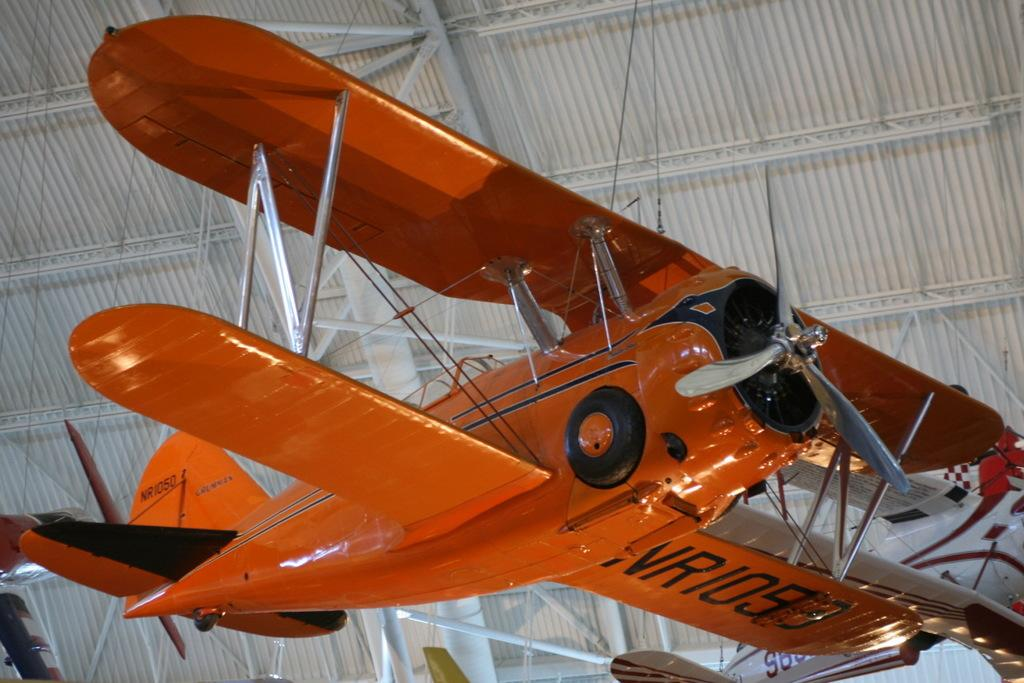What is the main subject of the image? The main subject of the image is an airplane. Where is the airplane located in the image? The airplane is in the center of the image. What can be seen above the airplane in the image? There is a roof visible at the top of the image. What other objects are present in the image besides the airplane and roof? There are rods present in the image. How many jellyfish can be seen swimming near the airplane in the image? There are no jellyfish present in the image; it features an airplane and a roof. What type of home is depicted in the image? The image does not show a home; it features an airplane and a roof. 